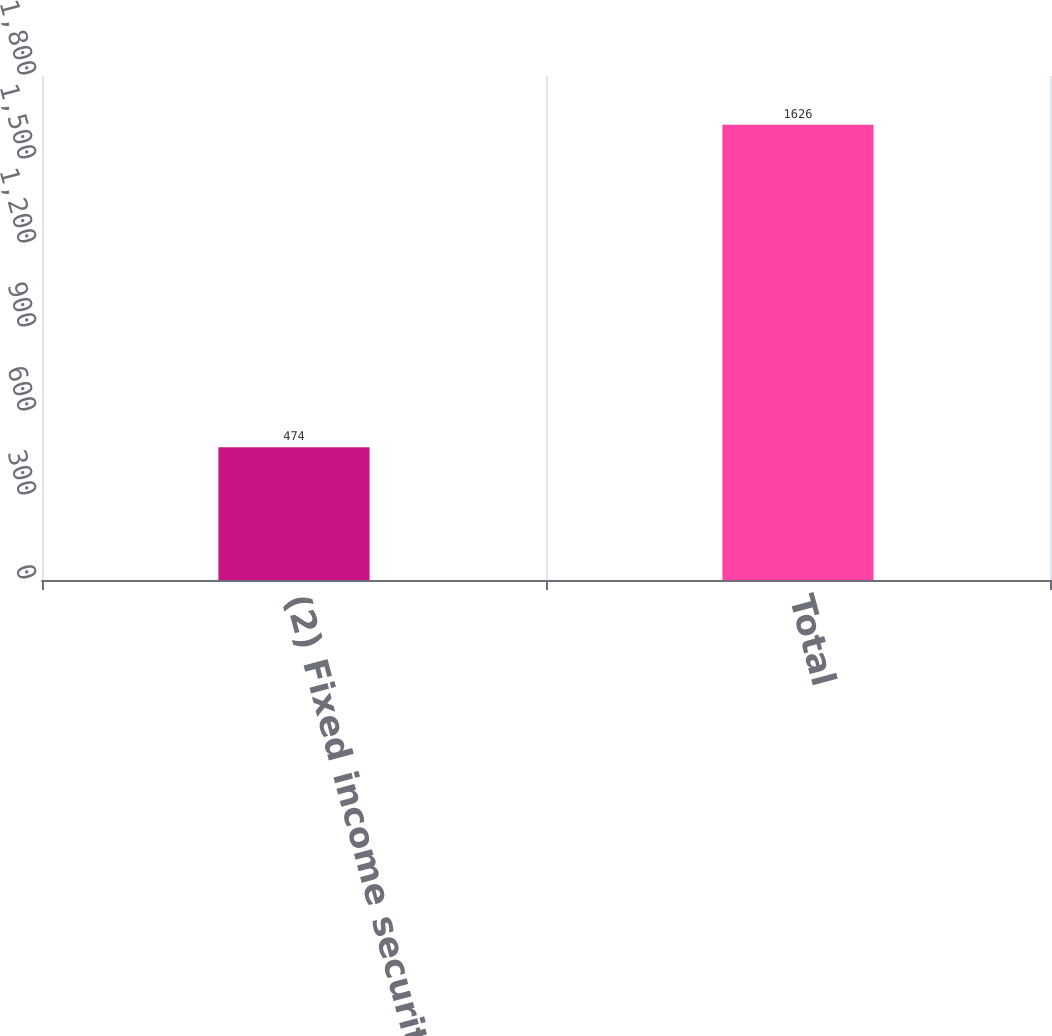Convert chart. <chart><loc_0><loc_0><loc_500><loc_500><bar_chart><fcel>(2) Fixed income securities<fcel>Total<nl><fcel>474<fcel>1626<nl></chart> 